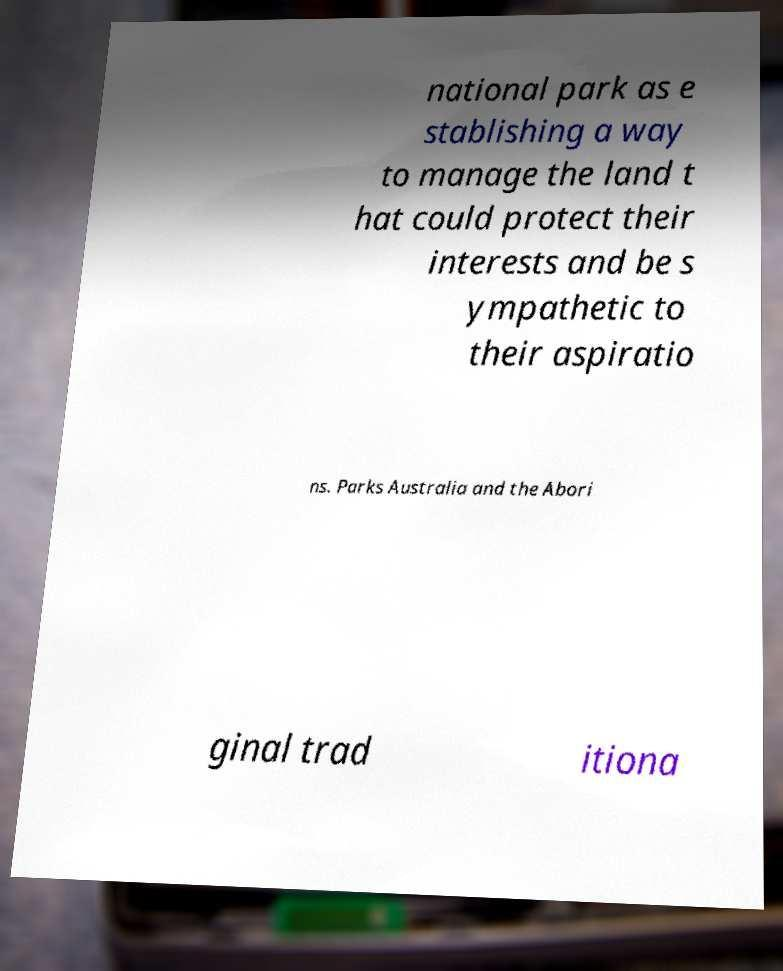What messages or text are displayed in this image? I need them in a readable, typed format. national park as e stablishing a way to manage the land t hat could protect their interests and be s ympathetic to their aspiratio ns. Parks Australia and the Abori ginal trad itiona 